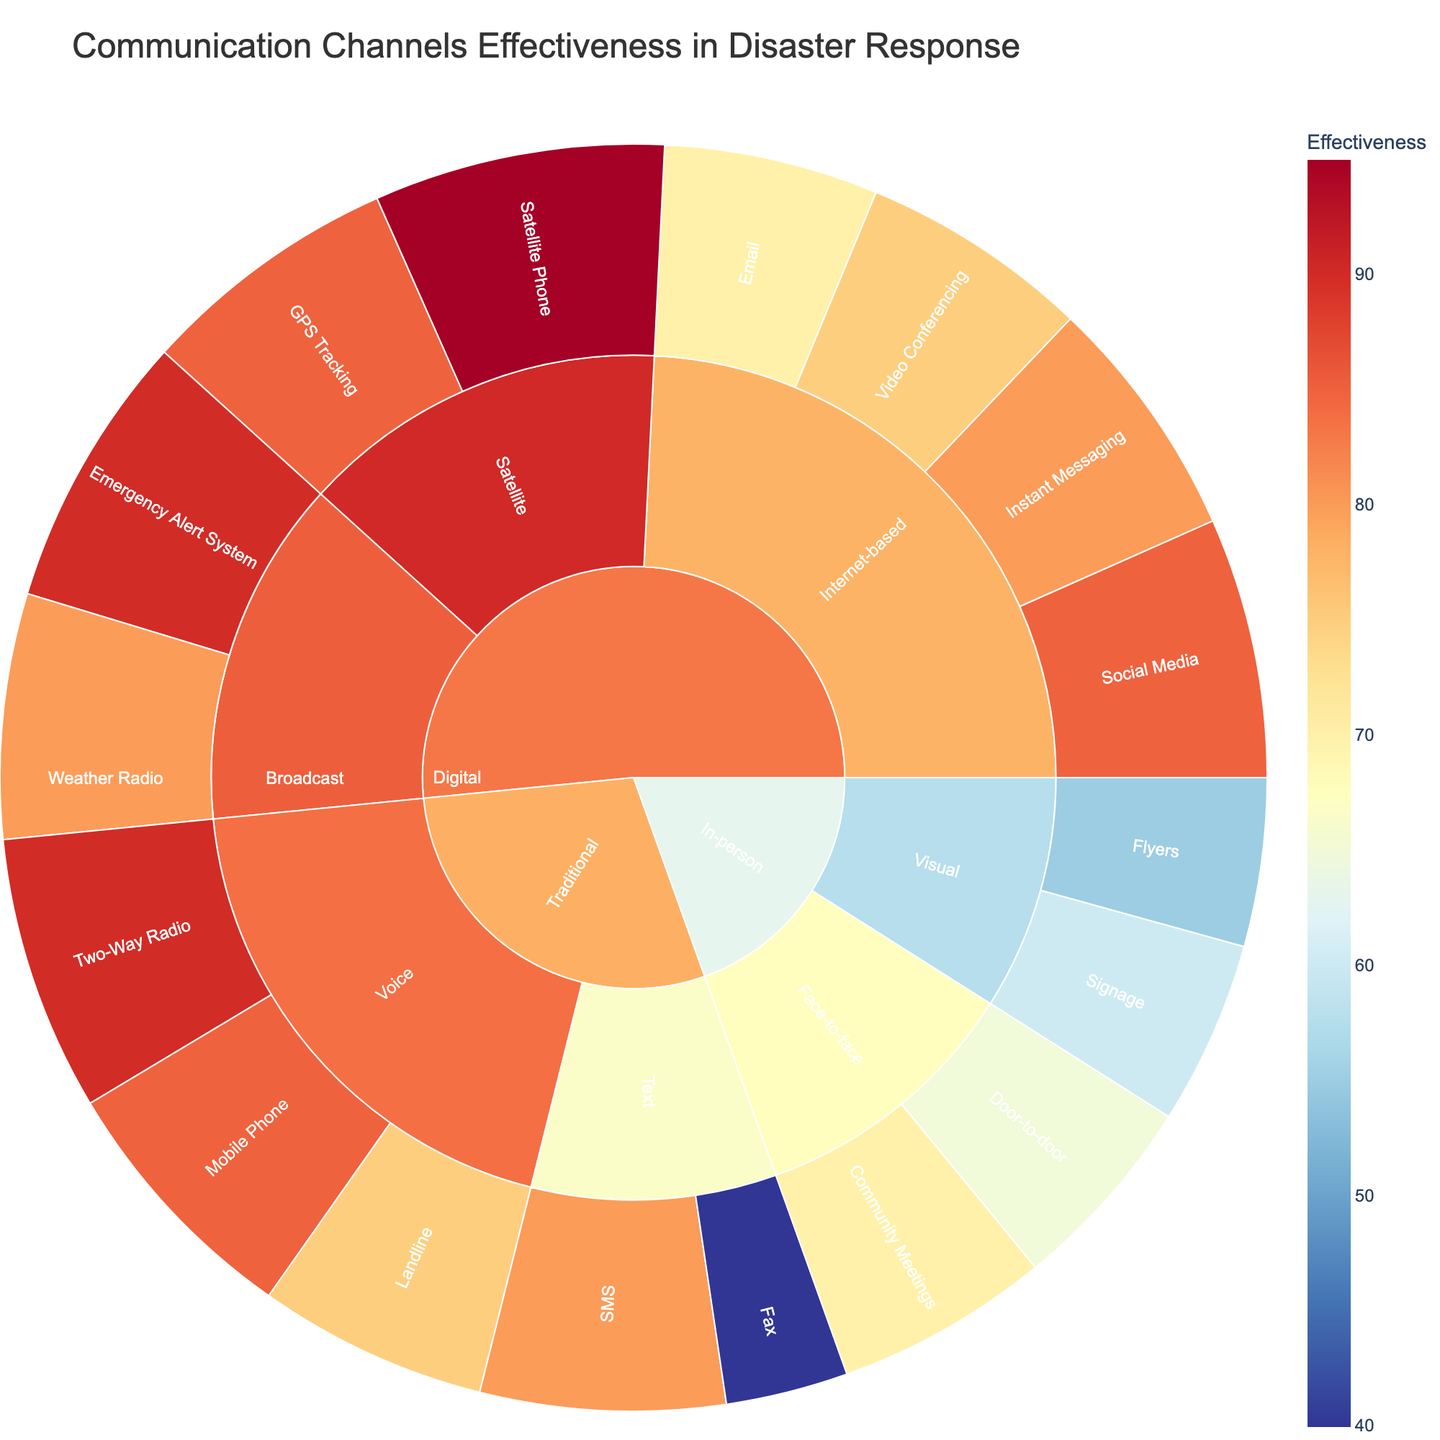What is the title of the plot? The title of the plot is displayed prominently at the top of the figure, providing a brief description of the chart's content.
Answer: Communication Channels Effectiveness in Disaster Response Which category has the highest effectiveness values overall? By examining the sunburst plot, we can look at the individual elements within each primary category and find the one with the highest effectiveness values.
Answer: Digital How does the effectiveness of SMS compare to that of Instant Messaging? To compare SMS and Instant Messaging, we need to look at their effectiveness values on the plot.
Answer: Instant Messaging is more effective than SMS What is the least effective channel under the Traditional category? We examine the subcategories under Traditional and compare their effectiveness values.
Answer: Fax Which subcategory within the Digital category shows the highest effectiveness? We look at each subcategory within Digital and identify the one with the highest effectiveness value.
Answer: Satellite How does the effectiveness of the Digital category compare to the Traditional category overall? We compare the combined effectiveness of all subcategories within the Digital and Traditional categories by observing their values.
Answer: Digital is more effective than Traditional Which is more effective: Community Meetings or Door-to-door communication? By examining the effectiveness values of both Community Meetings and Door-to-door communication in the In-person category, we determine the higher value.
Answer: Community Meetings What is the most effective channel within all categories? To find the most effective channel, we need to look at the outermost layer of the sunburst and identify the highest value.
Answer: Satellite Phone Are visual communication methods (Signage and Flyers) effective in disaster response? We evaluate Signage and Flyers under the In-person category to see their effectiveness values.
Answer: They are less effective compared to other channels What is the average effectiveness of Internet-based communication channels? We calculate the average effectiveness of Email, Social Media, Instant Messaging, and Video Conferencing.
Answer: (70 + 85 + 80 + 75) / 4 = 77.5 